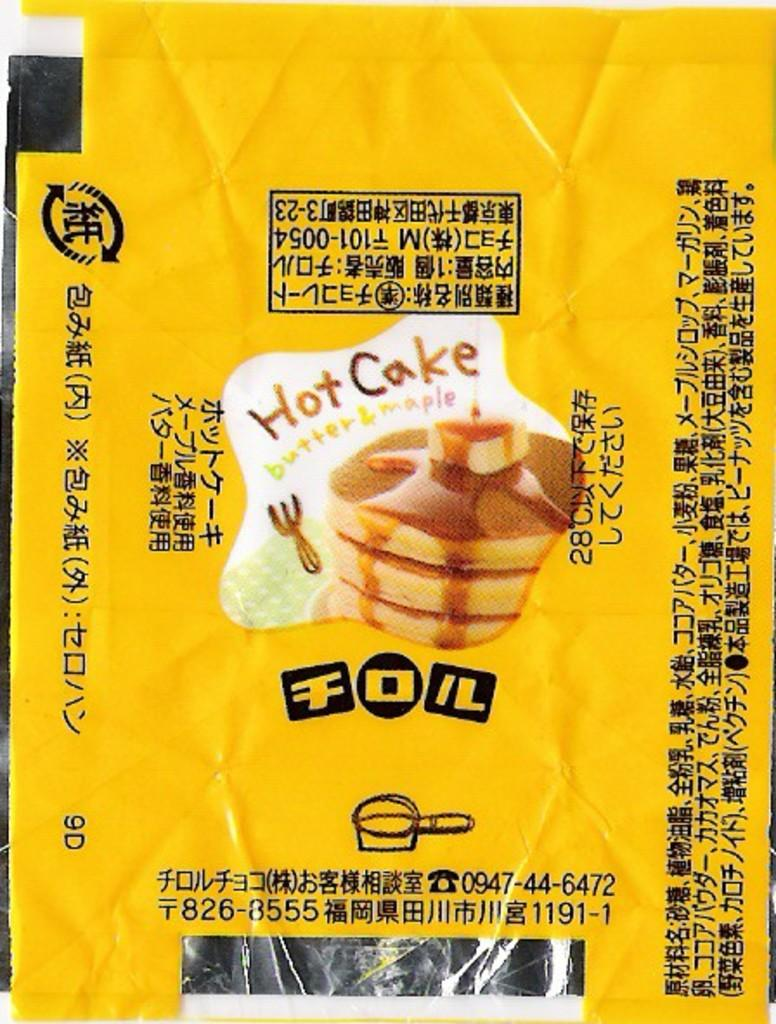Provide a one-sentence caption for the provided image. An advertisement for Hot Cakes with butter and maple. 